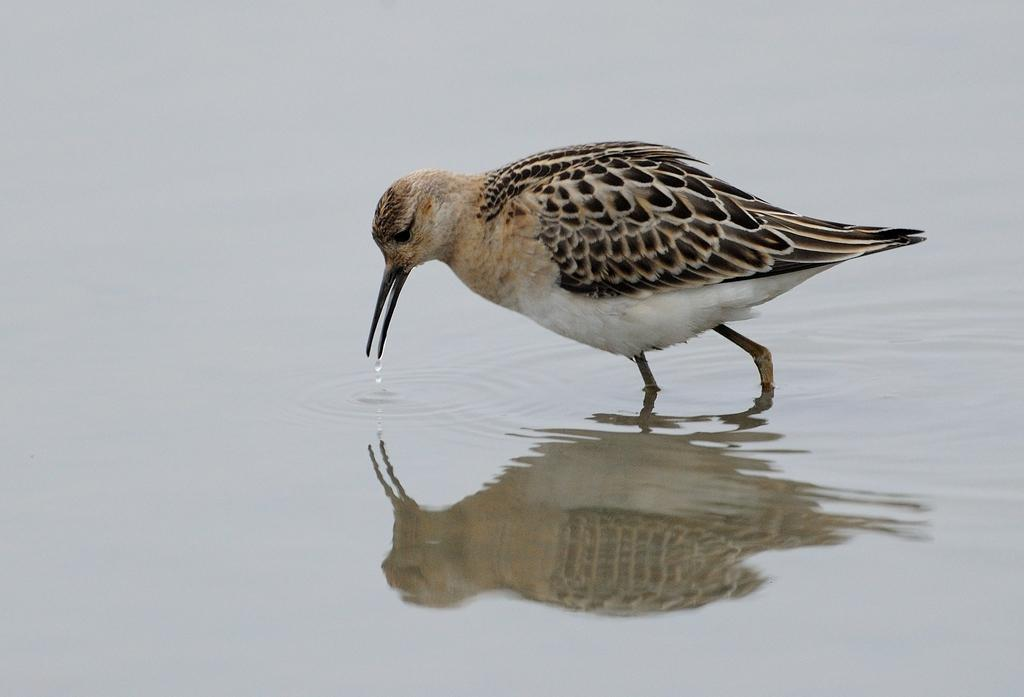What type of animal can be seen in the image? There is a bird in the image. What is the bird doing in the image? The bird is drinking water. Can you describe the environment in the image? There is water visible at the bottom of the image. What nerve is responsible for the bird's ability to drink water in the image? There is no information about the bird's nerves in the image, and it is not possible to determine which nerve is responsible for its ability to drink water. 